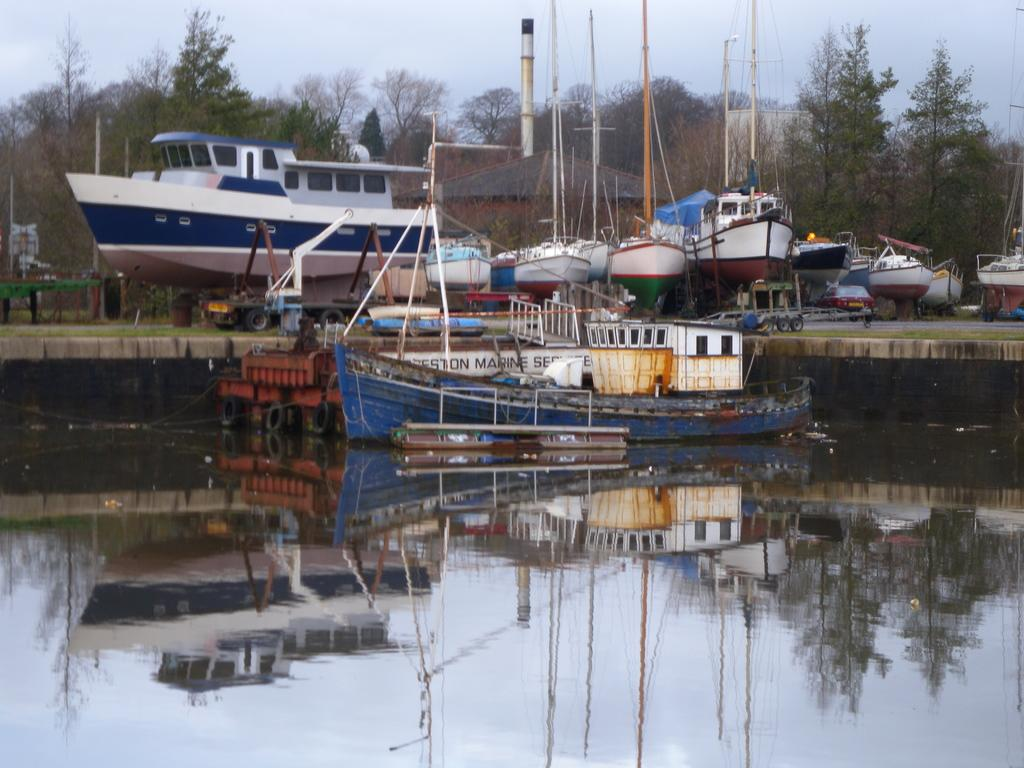What is the main subject of the image? The main subject of the image is a ship on the water surface. Can you describe the background of the image? In the background of the image, there are ships and a group of trees visible. What type of polish is being applied to the books in the image? There are no books or polish present in the image; it features a ship on the water surface and ships and trees in the background. 